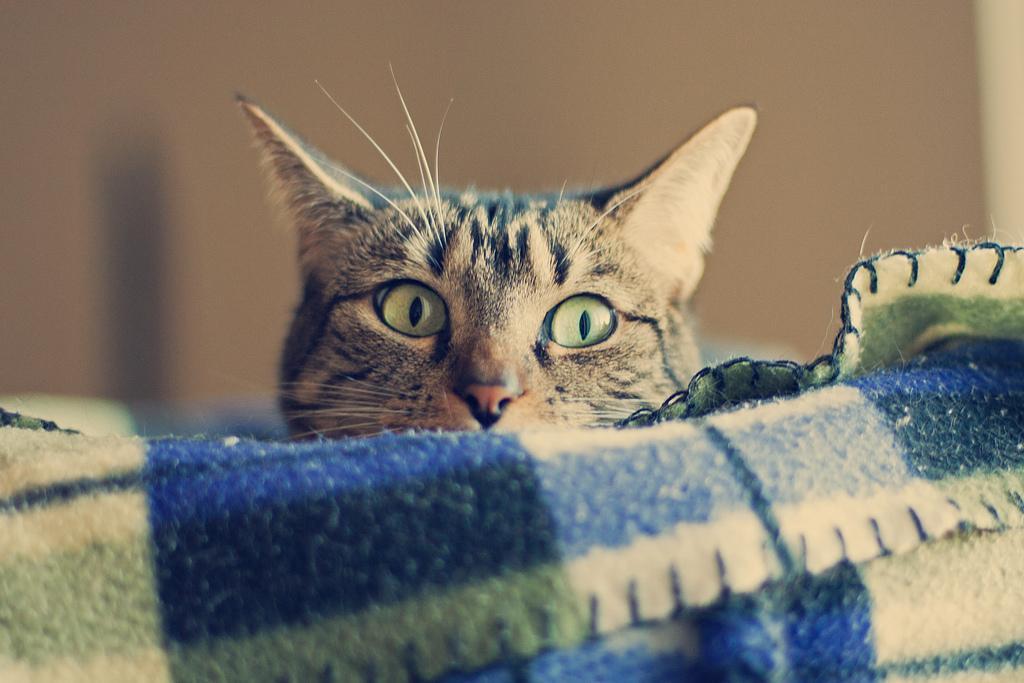How would you summarize this image in a sentence or two? In this picture there is a cat and we can see a cloth. In the background of the image it is blurry. 